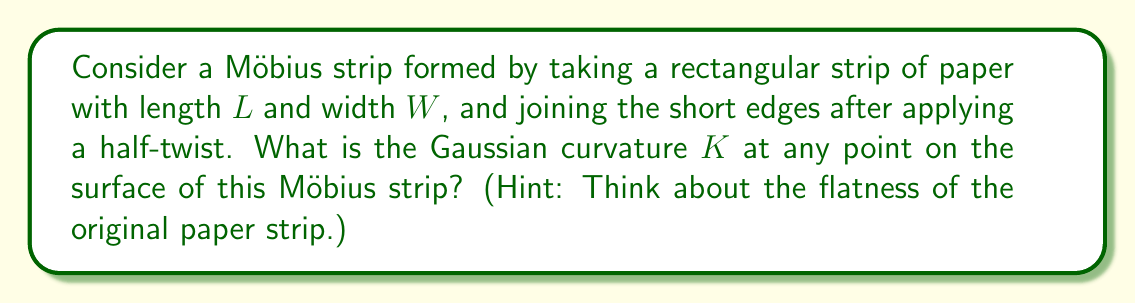Help me with this question. Let's approach this step-by-step:

1) First, recall that the Gaussian curvature $K$ is an intrinsic property of a surface, meaning it doesn't depend on how the surface is embedded in 3D space.

2) The Möbius strip is created from a flat rectangular piece of paper. Before twisting and joining the ends, the paper has zero Gaussian curvature everywhere because it's flat.

3) The key insight is that the process of twisting and joining the ends of the paper doesn't stretch or compress the paper locally. It only bends it.

4) Since Gaussian curvature is intrinsic, it isn't affected by bending without stretching or compressing. This is a fundamental principle in differential geometry.

5) Therefore, even after forming the Möbius strip, the Gaussian curvature at any point remains the same as it was on the flat paper.

6) The Gaussian curvature of a flat surface is zero everywhere.

Thus, we can conclude that the Gaussian curvature $K$ at any point on the Möbius strip is zero.

Note: This doesn't mean the Möbius strip is flat in 3D space. It has extrinsic curvature (which depends on how it's embedded in 3D space), but its intrinsic geometry, as measured by Gaussian curvature, is flat.
Answer: $K = 0$ 